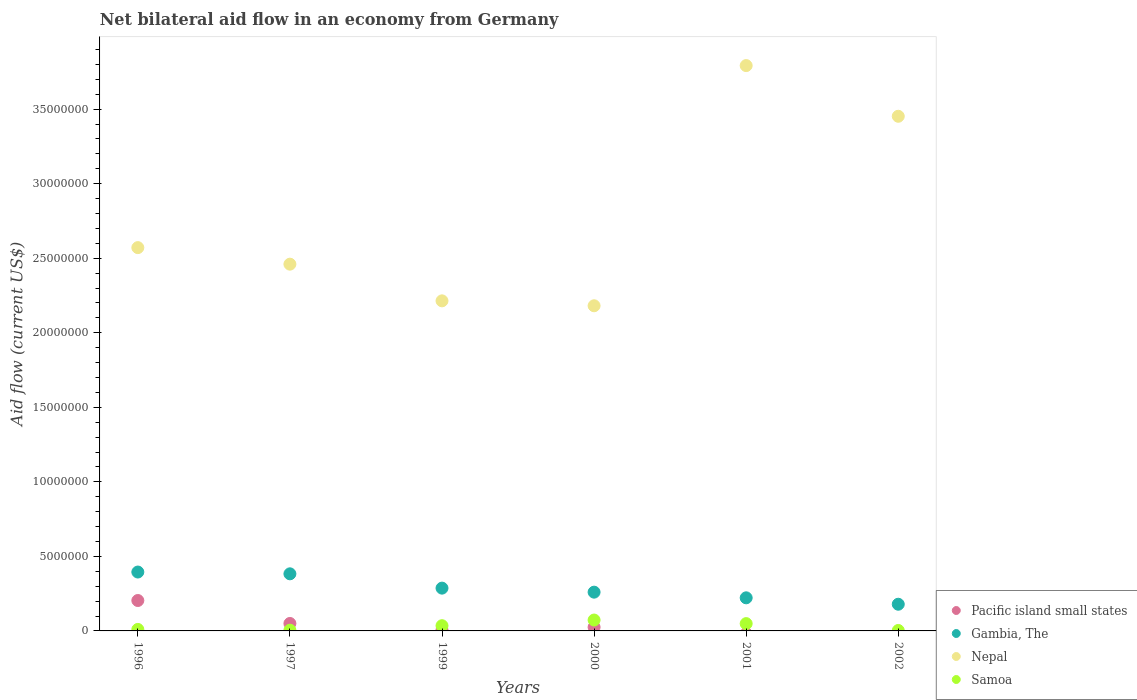How many different coloured dotlines are there?
Make the answer very short. 4. What is the net bilateral aid flow in Nepal in 1999?
Your response must be concise. 2.21e+07. Across all years, what is the maximum net bilateral aid flow in Pacific island small states?
Ensure brevity in your answer.  2.04e+06. Across all years, what is the minimum net bilateral aid flow in Samoa?
Your response must be concise. 3.00e+04. What is the total net bilateral aid flow in Nepal in the graph?
Your answer should be very brief. 1.67e+08. What is the difference between the net bilateral aid flow in Samoa in 1999 and that in 2000?
Give a very brief answer. -3.80e+05. What is the difference between the net bilateral aid flow in Samoa in 1999 and the net bilateral aid flow in Gambia, The in 1996?
Make the answer very short. -3.60e+06. What is the average net bilateral aid flow in Nepal per year?
Your response must be concise. 2.78e+07. In the year 1996, what is the difference between the net bilateral aid flow in Pacific island small states and net bilateral aid flow in Gambia, The?
Your answer should be very brief. -1.91e+06. In how many years, is the net bilateral aid flow in Nepal greater than 1000000 US$?
Keep it short and to the point. 6. What is the ratio of the net bilateral aid flow in Nepal in 1997 to that in 2002?
Keep it short and to the point. 0.71. Is the difference between the net bilateral aid flow in Pacific island small states in 1996 and 2000 greater than the difference between the net bilateral aid flow in Gambia, The in 1996 and 2000?
Provide a short and direct response. Yes. What is the difference between the highest and the second highest net bilateral aid flow in Samoa?
Keep it short and to the point. 2.40e+05. What is the difference between the highest and the lowest net bilateral aid flow in Nepal?
Your response must be concise. 1.61e+07. Is the sum of the net bilateral aid flow in Nepal in 2001 and 2002 greater than the maximum net bilateral aid flow in Gambia, The across all years?
Ensure brevity in your answer.  Yes. Is it the case that in every year, the sum of the net bilateral aid flow in Gambia, The and net bilateral aid flow in Samoa  is greater than the sum of net bilateral aid flow in Nepal and net bilateral aid flow in Pacific island small states?
Give a very brief answer. No. Is it the case that in every year, the sum of the net bilateral aid flow in Samoa and net bilateral aid flow in Gambia, The  is greater than the net bilateral aid flow in Pacific island small states?
Offer a very short reply. Yes. Is the net bilateral aid flow in Gambia, The strictly less than the net bilateral aid flow in Samoa over the years?
Ensure brevity in your answer.  No. How many years are there in the graph?
Provide a short and direct response. 6. Are the values on the major ticks of Y-axis written in scientific E-notation?
Offer a very short reply. No. Does the graph contain any zero values?
Provide a short and direct response. Yes. Does the graph contain grids?
Ensure brevity in your answer.  No. How many legend labels are there?
Ensure brevity in your answer.  4. How are the legend labels stacked?
Offer a very short reply. Vertical. What is the title of the graph?
Your response must be concise. Net bilateral aid flow in an economy from Germany. Does "Sudan" appear as one of the legend labels in the graph?
Make the answer very short. No. What is the Aid flow (current US$) in Pacific island small states in 1996?
Provide a succinct answer. 2.04e+06. What is the Aid flow (current US$) of Gambia, The in 1996?
Your answer should be very brief. 3.95e+06. What is the Aid flow (current US$) in Nepal in 1996?
Your response must be concise. 2.57e+07. What is the Aid flow (current US$) of Samoa in 1996?
Offer a very short reply. 1.00e+05. What is the Aid flow (current US$) of Gambia, The in 1997?
Make the answer very short. 3.83e+06. What is the Aid flow (current US$) in Nepal in 1997?
Make the answer very short. 2.46e+07. What is the Aid flow (current US$) in Gambia, The in 1999?
Offer a terse response. 2.87e+06. What is the Aid flow (current US$) of Nepal in 1999?
Offer a very short reply. 2.21e+07. What is the Aid flow (current US$) in Samoa in 1999?
Your answer should be compact. 3.50e+05. What is the Aid flow (current US$) in Pacific island small states in 2000?
Ensure brevity in your answer.  2.50e+05. What is the Aid flow (current US$) of Gambia, The in 2000?
Your response must be concise. 2.60e+06. What is the Aid flow (current US$) in Nepal in 2000?
Your answer should be compact. 2.18e+07. What is the Aid flow (current US$) in Samoa in 2000?
Your answer should be very brief. 7.30e+05. What is the Aid flow (current US$) of Gambia, The in 2001?
Your response must be concise. 2.22e+06. What is the Aid flow (current US$) of Nepal in 2001?
Your response must be concise. 3.79e+07. What is the Aid flow (current US$) in Pacific island small states in 2002?
Your response must be concise. 0. What is the Aid flow (current US$) in Gambia, The in 2002?
Your answer should be very brief. 1.79e+06. What is the Aid flow (current US$) of Nepal in 2002?
Keep it short and to the point. 3.45e+07. Across all years, what is the maximum Aid flow (current US$) in Pacific island small states?
Provide a short and direct response. 2.04e+06. Across all years, what is the maximum Aid flow (current US$) of Gambia, The?
Your response must be concise. 3.95e+06. Across all years, what is the maximum Aid flow (current US$) in Nepal?
Provide a succinct answer. 3.79e+07. Across all years, what is the maximum Aid flow (current US$) of Samoa?
Offer a terse response. 7.30e+05. Across all years, what is the minimum Aid flow (current US$) of Pacific island small states?
Your answer should be compact. 0. Across all years, what is the minimum Aid flow (current US$) in Gambia, The?
Provide a succinct answer. 1.79e+06. Across all years, what is the minimum Aid flow (current US$) of Nepal?
Ensure brevity in your answer.  2.18e+07. Across all years, what is the minimum Aid flow (current US$) in Samoa?
Your response must be concise. 3.00e+04. What is the total Aid flow (current US$) in Pacific island small states in the graph?
Give a very brief answer. 2.85e+06. What is the total Aid flow (current US$) in Gambia, The in the graph?
Your answer should be very brief. 1.73e+07. What is the total Aid flow (current US$) of Nepal in the graph?
Ensure brevity in your answer.  1.67e+08. What is the total Aid flow (current US$) in Samoa in the graph?
Offer a very short reply. 1.75e+06. What is the difference between the Aid flow (current US$) in Pacific island small states in 1996 and that in 1997?
Keep it short and to the point. 1.54e+06. What is the difference between the Aid flow (current US$) of Nepal in 1996 and that in 1997?
Keep it short and to the point. 1.11e+06. What is the difference between the Aid flow (current US$) of Pacific island small states in 1996 and that in 1999?
Offer a terse response. 1.98e+06. What is the difference between the Aid flow (current US$) in Gambia, The in 1996 and that in 1999?
Provide a short and direct response. 1.08e+06. What is the difference between the Aid flow (current US$) of Nepal in 1996 and that in 1999?
Provide a short and direct response. 3.57e+06. What is the difference between the Aid flow (current US$) of Pacific island small states in 1996 and that in 2000?
Keep it short and to the point. 1.79e+06. What is the difference between the Aid flow (current US$) in Gambia, The in 1996 and that in 2000?
Your answer should be very brief. 1.35e+06. What is the difference between the Aid flow (current US$) of Nepal in 1996 and that in 2000?
Give a very brief answer. 3.90e+06. What is the difference between the Aid flow (current US$) of Samoa in 1996 and that in 2000?
Your answer should be compact. -6.30e+05. What is the difference between the Aid flow (current US$) in Gambia, The in 1996 and that in 2001?
Ensure brevity in your answer.  1.73e+06. What is the difference between the Aid flow (current US$) in Nepal in 1996 and that in 2001?
Provide a succinct answer. -1.22e+07. What is the difference between the Aid flow (current US$) in Samoa in 1996 and that in 2001?
Offer a terse response. -3.90e+05. What is the difference between the Aid flow (current US$) in Gambia, The in 1996 and that in 2002?
Give a very brief answer. 2.16e+06. What is the difference between the Aid flow (current US$) of Nepal in 1996 and that in 2002?
Make the answer very short. -8.81e+06. What is the difference between the Aid flow (current US$) of Samoa in 1996 and that in 2002?
Provide a succinct answer. 7.00e+04. What is the difference between the Aid flow (current US$) of Gambia, The in 1997 and that in 1999?
Your response must be concise. 9.60e+05. What is the difference between the Aid flow (current US$) of Nepal in 1997 and that in 1999?
Offer a terse response. 2.46e+06. What is the difference between the Aid flow (current US$) in Samoa in 1997 and that in 1999?
Your response must be concise. -3.00e+05. What is the difference between the Aid flow (current US$) of Gambia, The in 1997 and that in 2000?
Your answer should be very brief. 1.23e+06. What is the difference between the Aid flow (current US$) in Nepal in 1997 and that in 2000?
Keep it short and to the point. 2.79e+06. What is the difference between the Aid flow (current US$) in Samoa in 1997 and that in 2000?
Offer a terse response. -6.80e+05. What is the difference between the Aid flow (current US$) of Gambia, The in 1997 and that in 2001?
Your response must be concise. 1.61e+06. What is the difference between the Aid flow (current US$) in Nepal in 1997 and that in 2001?
Give a very brief answer. -1.33e+07. What is the difference between the Aid flow (current US$) of Samoa in 1997 and that in 2001?
Provide a short and direct response. -4.40e+05. What is the difference between the Aid flow (current US$) in Gambia, The in 1997 and that in 2002?
Your answer should be compact. 2.04e+06. What is the difference between the Aid flow (current US$) of Nepal in 1997 and that in 2002?
Ensure brevity in your answer.  -9.92e+06. What is the difference between the Aid flow (current US$) in Samoa in 1997 and that in 2002?
Make the answer very short. 2.00e+04. What is the difference between the Aid flow (current US$) of Gambia, The in 1999 and that in 2000?
Your answer should be very brief. 2.70e+05. What is the difference between the Aid flow (current US$) in Nepal in 1999 and that in 2000?
Ensure brevity in your answer.  3.30e+05. What is the difference between the Aid flow (current US$) in Samoa in 1999 and that in 2000?
Your answer should be compact. -3.80e+05. What is the difference between the Aid flow (current US$) in Gambia, The in 1999 and that in 2001?
Give a very brief answer. 6.50e+05. What is the difference between the Aid flow (current US$) in Nepal in 1999 and that in 2001?
Make the answer very short. -1.58e+07. What is the difference between the Aid flow (current US$) in Gambia, The in 1999 and that in 2002?
Give a very brief answer. 1.08e+06. What is the difference between the Aid flow (current US$) in Nepal in 1999 and that in 2002?
Provide a succinct answer. -1.24e+07. What is the difference between the Aid flow (current US$) in Gambia, The in 2000 and that in 2001?
Your answer should be very brief. 3.80e+05. What is the difference between the Aid flow (current US$) of Nepal in 2000 and that in 2001?
Give a very brief answer. -1.61e+07. What is the difference between the Aid flow (current US$) in Gambia, The in 2000 and that in 2002?
Give a very brief answer. 8.10e+05. What is the difference between the Aid flow (current US$) in Nepal in 2000 and that in 2002?
Ensure brevity in your answer.  -1.27e+07. What is the difference between the Aid flow (current US$) in Gambia, The in 2001 and that in 2002?
Your response must be concise. 4.30e+05. What is the difference between the Aid flow (current US$) in Nepal in 2001 and that in 2002?
Provide a short and direct response. 3.40e+06. What is the difference between the Aid flow (current US$) of Samoa in 2001 and that in 2002?
Offer a terse response. 4.60e+05. What is the difference between the Aid flow (current US$) of Pacific island small states in 1996 and the Aid flow (current US$) of Gambia, The in 1997?
Ensure brevity in your answer.  -1.79e+06. What is the difference between the Aid flow (current US$) of Pacific island small states in 1996 and the Aid flow (current US$) of Nepal in 1997?
Your response must be concise. -2.26e+07. What is the difference between the Aid flow (current US$) of Pacific island small states in 1996 and the Aid flow (current US$) of Samoa in 1997?
Offer a terse response. 1.99e+06. What is the difference between the Aid flow (current US$) of Gambia, The in 1996 and the Aid flow (current US$) of Nepal in 1997?
Your answer should be compact. -2.06e+07. What is the difference between the Aid flow (current US$) of Gambia, The in 1996 and the Aid flow (current US$) of Samoa in 1997?
Give a very brief answer. 3.90e+06. What is the difference between the Aid flow (current US$) in Nepal in 1996 and the Aid flow (current US$) in Samoa in 1997?
Make the answer very short. 2.57e+07. What is the difference between the Aid flow (current US$) of Pacific island small states in 1996 and the Aid flow (current US$) of Gambia, The in 1999?
Your answer should be very brief. -8.30e+05. What is the difference between the Aid flow (current US$) of Pacific island small states in 1996 and the Aid flow (current US$) of Nepal in 1999?
Offer a very short reply. -2.01e+07. What is the difference between the Aid flow (current US$) of Pacific island small states in 1996 and the Aid flow (current US$) of Samoa in 1999?
Make the answer very short. 1.69e+06. What is the difference between the Aid flow (current US$) in Gambia, The in 1996 and the Aid flow (current US$) in Nepal in 1999?
Make the answer very short. -1.82e+07. What is the difference between the Aid flow (current US$) of Gambia, The in 1996 and the Aid flow (current US$) of Samoa in 1999?
Make the answer very short. 3.60e+06. What is the difference between the Aid flow (current US$) of Nepal in 1996 and the Aid flow (current US$) of Samoa in 1999?
Provide a succinct answer. 2.54e+07. What is the difference between the Aid flow (current US$) in Pacific island small states in 1996 and the Aid flow (current US$) in Gambia, The in 2000?
Offer a very short reply. -5.60e+05. What is the difference between the Aid flow (current US$) of Pacific island small states in 1996 and the Aid flow (current US$) of Nepal in 2000?
Ensure brevity in your answer.  -1.98e+07. What is the difference between the Aid flow (current US$) of Pacific island small states in 1996 and the Aid flow (current US$) of Samoa in 2000?
Ensure brevity in your answer.  1.31e+06. What is the difference between the Aid flow (current US$) in Gambia, The in 1996 and the Aid flow (current US$) in Nepal in 2000?
Give a very brief answer. -1.79e+07. What is the difference between the Aid flow (current US$) of Gambia, The in 1996 and the Aid flow (current US$) of Samoa in 2000?
Ensure brevity in your answer.  3.22e+06. What is the difference between the Aid flow (current US$) in Nepal in 1996 and the Aid flow (current US$) in Samoa in 2000?
Your response must be concise. 2.50e+07. What is the difference between the Aid flow (current US$) of Pacific island small states in 1996 and the Aid flow (current US$) of Nepal in 2001?
Provide a short and direct response. -3.59e+07. What is the difference between the Aid flow (current US$) of Pacific island small states in 1996 and the Aid flow (current US$) of Samoa in 2001?
Provide a short and direct response. 1.55e+06. What is the difference between the Aid flow (current US$) of Gambia, The in 1996 and the Aid flow (current US$) of Nepal in 2001?
Give a very brief answer. -3.40e+07. What is the difference between the Aid flow (current US$) of Gambia, The in 1996 and the Aid flow (current US$) of Samoa in 2001?
Provide a succinct answer. 3.46e+06. What is the difference between the Aid flow (current US$) in Nepal in 1996 and the Aid flow (current US$) in Samoa in 2001?
Give a very brief answer. 2.52e+07. What is the difference between the Aid flow (current US$) of Pacific island small states in 1996 and the Aid flow (current US$) of Gambia, The in 2002?
Your response must be concise. 2.50e+05. What is the difference between the Aid flow (current US$) in Pacific island small states in 1996 and the Aid flow (current US$) in Nepal in 2002?
Offer a terse response. -3.25e+07. What is the difference between the Aid flow (current US$) in Pacific island small states in 1996 and the Aid flow (current US$) in Samoa in 2002?
Your answer should be very brief. 2.01e+06. What is the difference between the Aid flow (current US$) in Gambia, The in 1996 and the Aid flow (current US$) in Nepal in 2002?
Offer a very short reply. -3.06e+07. What is the difference between the Aid flow (current US$) in Gambia, The in 1996 and the Aid flow (current US$) in Samoa in 2002?
Offer a terse response. 3.92e+06. What is the difference between the Aid flow (current US$) of Nepal in 1996 and the Aid flow (current US$) of Samoa in 2002?
Keep it short and to the point. 2.57e+07. What is the difference between the Aid flow (current US$) in Pacific island small states in 1997 and the Aid flow (current US$) in Gambia, The in 1999?
Your answer should be compact. -2.37e+06. What is the difference between the Aid flow (current US$) of Pacific island small states in 1997 and the Aid flow (current US$) of Nepal in 1999?
Give a very brief answer. -2.16e+07. What is the difference between the Aid flow (current US$) of Gambia, The in 1997 and the Aid flow (current US$) of Nepal in 1999?
Provide a succinct answer. -1.83e+07. What is the difference between the Aid flow (current US$) in Gambia, The in 1997 and the Aid flow (current US$) in Samoa in 1999?
Provide a succinct answer. 3.48e+06. What is the difference between the Aid flow (current US$) in Nepal in 1997 and the Aid flow (current US$) in Samoa in 1999?
Your answer should be very brief. 2.42e+07. What is the difference between the Aid flow (current US$) in Pacific island small states in 1997 and the Aid flow (current US$) in Gambia, The in 2000?
Your answer should be very brief. -2.10e+06. What is the difference between the Aid flow (current US$) of Pacific island small states in 1997 and the Aid flow (current US$) of Nepal in 2000?
Ensure brevity in your answer.  -2.13e+07. What is the difference between the Aid flow (current US$) in Gambia, The in 1997 and the Aid flow (current US$) in Nepal in 2000?
Provide a short and direct response. -1.80e+07. What is the difference between the Aid flow (current US$) in Gambia, The in 1997 and the Aid flow (current US$) in Samoa in 2000?
Keep it short and to the point. 3.10e+06. What is the difference between the Aid flow (current US$) of Nepal in 1997 and the Aid flow (current US$) of Samoa in 2000?
Make the answer very short. 2.39e+07. What is the difference between the Aid flow (current US$) of Pacific island small states in 1997 and the Aid flow (current US$) of Gambia, The in 2001?
Give a very brief answer. -1.72e+06. What is the difference between the Aid flow (current US$) in Pacific island small states in 1997 and the Aid flow (current US$) in Nepal in 2001?
Ensure brevity in your answer.  -3.74e+07. What is the difference between the Aid flow (current US$) in Pacific island small states in 1997 and the Aid flow (current US$) in Samoa in 2001?
Offer a terse response. 10000. What is the difference between the Aid flow (current US$) of Gambia, The in 1997 and the Aid flow (current US$) of Nepal in 2001?
Your answer should be very brief. -3.41e+07. What is the difference between the Aid flow (current US$) of Gambia, The in 1997 and the Aid flow (current US$) of Samoa in 2001?
Your answer should be very brief. 3.34e+06. What is the difference between the Aid flow (current US$) of Nepal in 1997 and the Aid flow (current US$) of Samoa in 2001?
Offer a very short reply. 2.41e+07. What is the difference between the Aid flow (current US$) in Pacific island small states in 1997 and the Aid flow (current US$) in Gambia, The in 2002?
Your answer should be compact. -1.29e+06. What is the difference between the Aid flow (current US$) in Pacific island small states in 1997 and the Aid flow (current US$) in Nepal in 2002?
Offer a very short reply. -3.40e+07. What is the difference between the Aid flow (current US$) in Pacific island small states in 1997 and the Aid flow (current US$) in Samoa in 2002?
Make the answer very short. 4.70e+05. What is the difference between the Aid flow (current US$) of Gambia, The in 1997 and the Aid flow (current US$) of Nepal in 2002?
Make the answer very short. -3.07e+07. What is the difference between the Aid flow (current US$) of Gambia, The in 1997 and the Aid flow (current US$) of Samoa in 2002?
Make the answer very short. 3.80e+06. What is the difference between the Aid flow (current US$) of Nepal in 1997 and the Aid flow (current US$) of Samoa in 2002?
Offer a terse response. 2.46e+07. What is the difference between the Aid flow (current US$) in Pacific island small states in 1999 and the Aid flow (current US$) in Gambia, The in 2000?
Provide a succinct answer. -2.54e+06. What is the difference between the Aid flow (current US$) of Pacific island small states in 1999 and the Aid flow (current US$) of Nepal in 2000?
Provide a succinct answer. -2.18e+07. What is the difference between the Aid flow (current US$) in Pacific island small states in 1999 and the Aid flow (current US$) in Samoa in 2000?
Your answer should be compact. -6.70e+05. What is the difference between the Aid flow (current US$) of Gambia, The in 1999 and the Aid flow (current US$) of Nepal in 2000?
Give a very brief answer. -1.89e+07. What is the difference between the Aid flow (current US$) in Gambia, The in 1999 and the Aid flow (current US$) in Samoa in 2000?
Give a very brief answer. 2.14e+06. What is the difference between the Aid flow (current US$) in Nepal in 1999 and the Aid flow (current US$) in Samoa in 2000?
Ensure brevity in your answer.  2.14e+07. What is the difference between the Aid flow (current US$) of Pacific island small states in 1999 and the Aid flow (current US$) of Gambia, The in 2001?
Offer a very short reply. -2.16e+06. What is the difference between the Aid flow (current US$) in Pacific island small states in 1999 and the Aid flow (current US$) in Nepal in 2001?
Provide a short and direct response. -3.79e+07. What is the difference between the Aid flow (current US$) in Pacific island small states in 1999 and the Aid flow (current US$) in Samoa in 2001?
Your response must be concise. -4.30e+05. What is the difference between the Aid flow (current US$) in Gambia, The in 1999 and the Aid flow (current US$) in Nepal in 2001?
Provide a succinct answer. -3.50e+07. What is the difference between the Aid flow (current US$) of Gambia, The in 1999 and the Aid flow (current US$) of Samoa in 2001?
Keep it short and to the point. 2.38e+06. What is the difference between the Aid flow (current US$) in Nepal in 1999 and the Aid flow (current US$) in Samoa in 2001?
Your answer should be compact. 2.16e+07. What is the difference between the Aid flow (current US$) of Pacific island small states in 1999 and the Aid flow (current US$) of Gambia, The in 2002?
Your answer should be compact. -1.73e+06. What is the difference between the Aid flow (current US$) of Pacific island small states in 1999 and the Aid flow (current US$) of Nepal in 2002?
Offer a very short reply. -3.45e+07. What is the difference between the Aid flow (current US$) of Gambia, The in 1999 and the Aid flow (current US$) of Nepal in 2002?
Ensure brevity in your answer.  -3.16e+07. What is the difference between the Aid flow (current US$) in Gambia, The in 1999 and the Aid flow (current US$) in Samoa in 2002?
Your answer should be compact. 2.84e+06. What is the difference between the Aid flow (current US$) in Nepal in 1999 and the Aid flow (current US$) in Samoa in 2002?
Ensure brevity in your answer.  2.21e+07. What is the difference between the Aid flow (current US$) of Pacific island small states in 2000 and the Aid flow (current US$) of Gambia, The in 2001?
Offer a terse response. -1.97e+06. What is the difference between the Aid flow (current US$) of Pacific island small states in 2000 and the Aid flow (current US$) of Nepal in 2001?
Offer a very short reply. -3.77e+07. What is the difference between the Aid flow (current US$) of Gambia, The in 2000 and the Aid flow (current US$) of Nepal in 2001?
Provide a succinct answer. -3.53e+07. What is the difference between the Aid flow (current US$) in Gambia, The in 2000 and the Aid flow (current US$) in Samoa in 2001?
Offer a very short reply. 2.11e+06. What is the difference between the Aid flow (current US$) of Nepal in 2000 and the Aid flow (current US$) of Samoa in 2001?
Your answer should be compact. 2.13e+07. What is the difference between the Aid flow (current US$) of Pacific island small states in 2000 and the Aid flow (current US$) of Gambia, The in 2002?
Give a very brief answer. -1.54e+06. What is the difference between the Aid flow (current US$) of Pacific island small states in 2000 and the Aid flow (current US$) of Nepal in 2002?
Provide a succinct answer. -3.43e+07. What is the difference between the Aid flow (current US$) of Pacific island small states in 2000 and the Aid flow (current US$) of Samoa in 2002?
Your response must be concise. 2.20e+05. What is the difference between the Aid flow (current US$) of Gambia, The in 2000 and the Aid flow (current US$) of Nepal in 2002?
Ensure brevity in your answer.  -3.19e+07. What is the difference between the Aid flow (current US$) of Gambia, The in 2000 and the Aid flow (current US$) of Samoa in 2002?
Give a very brief answer. 2.57e+06. What is the difference between the Aid flow (current US$) of Nepal in 2000 and the Aid flow (current US$) of Samoa in 2002?
Give a very brief answer. 2.18e+07. What is the difference between the Aid flow (current US$) of Gambia, The in 2001 and the Aid flow (current US$) of Nepal in 2002?
Your answer should be compact. -3.23e+07. What is the difference between the Aid flow (current US$) in Gambia, The in 2001 and the Aid flow (current US$) in Samoa in 2002?
Offer a terse response. 2.19e+06. What is the difference between the Aid flow (current US$) in Nepal in 2001 and the Aid flow (current US$) in Samoa in 2002?
Ensure brevity in your answer.  3.79e+07. What is the average Aid flow (current US$) in Pacific island small states per year?
Provide a short and direct response. 4.75e+05. What is the average Aid flow (current US$) in Gambia, The per year?
Give a very brief answer. 2.88e+06. What is the average Aid flow (current US$) in Nepal per year?
Your answer should be very brief. 2.78e+07. What is the average Aid flow (current US$) of Samoa per year?
Provide a succinct answer. 2.92e+05. In the year 1996, what is the difference between the Aid flow (current US$) of Pacific island small states and Aid flow (current US$) of Gambia, The?
Keep it short and to the point. -1.91e+06. In the year 1996, what is the difference between the Aid flow (current US$) in Pacific island small states and Aid flow (current US$) in Nepal?
Provide a succinct answer. -2.37e+07. In the year 1996, what is the difference between the Aid flow (current US$) of Pacific island small states and Aid flow (current US$) of Samoa?
Your answer should be compact. 1.94e+06. In the year 1996, what is the difference between the Aid flow (current US$) of Gambia, The and Aid flow (current US$) of Nepal?
Ensure brevity in your answer.  -2.18e+07. In the year 1996, what is the difference between the Aid flow (current US$) of Gambia, The and Aid flow (current US$) of Samoa?
Ensure brevity in your answer.  3.85e+06. In the year 1996, what is the difference between the Aid flow (current US$) in Nepal and Aid flow (current US$) in Samoa?
Your answer should be compact. 2.56e+07. In the year 1997, what is the difference between the Aid flow (current US$) in Pacific island small states and Aid flow (current US$) in Gambia, The?
Your answer should be compact. -3.33e+06. In the year 1997, what is the difference between the Aid flow (current US$) of Pacific island small states and Aid flow (current US$) of Nepal?
Your answer should be very brief. -2.41e+07. In the year 1997, what is the difference between the Aid flow (current US$) in Gambia, The and Aid flow (current US$) in Nepal?
Provide a succinct answer. -2.08e+07. In the year 1997, what is the difference between the Aid flow (current US$) of Gambia, The and Aid flow (current US$) of Samoa?
Your response must be concise. 3.78e+06. In the year 1997, what is the difference between the Aid flow (current US$) of Nepal and Aid flow (current US$) of Samoa?
Offer a terse response. 2.46e+07. In the year 1999, what is the difference between the Aid flow (current US$) of Pacific island small states and Aid flow (current US$) of Gambia, The?
Offer a very short reply. -2.81e+06. In the year 1999, what is the difference between the Aid flow (current US$) in Pacific island small states and Aid flow (current US$) in Nepal?
Provide a short and direct response. -2.21e+07. In the year 1999, what is the difference between the Aid flow (current US$) in Pacific island small states and Aid flow (current US$) in Samoa?
Give a very brief answer. -2.90e+05. In the year 1999, what is the difference between the Aid flow (current US$) of Gambia, The and Aid flow (current US$) of Nepal?
Provide a succinct answer. -1.93e+07. In the year 1999, what is the difference between the Aid flow (current US$) of Gambia, The and Aid flow (current US$) of Samoa?
Offer a very short reply. 2.52e+06. In the year 1999, what is the difference between the Aid flow (current US$) of Nepal and Aid flow (current US$) of Samoa?
Make the answer very short. 2.18e+07. In the year 2000, what is the difference between the Aid flow (current US$) in Pacific island small states and Aid flow (current US$) in Gambia, The?
Ensure brevity in your answer.  -2.35e+06. In the year 2000, what is the difference between the Aid flow (current US$) of Pacific island small states and Aid flow (current US$) of Nepal?
Provide a succinct answer. -2.16e+07. In the year 2000, what is the difference between the Aid flow (current US$) of Pacific island small states and Aid flow (current US$) of Samoa?
Offer a terse response. -4.80e+05. In the year 2000, what is the difference between the Aid flow (current US$) of Gambia, The and Aid flow (current US$) of Nepal?
Ensure brevity in your answer.  -1.92e+07. In the year 2000, what is the difference between the Aid flow (current US$) in Gambia, The and Aid flow (current US$) in Samoa?
Keep it short and to the point. 1.87e+06. In the year 2000, what is the difference between the Aid flow (current US$) of Nepal and Aid flow (current US$) of Samoa?
Provide a short and direct response. 2.11e+07. In the year 2001, what is the difference between the Aid flow (current US$) of Gambia, The and Aid flow (current US$) of Nepal?
Make the answer very short. -3.57e+07. In the year 2001, what is the difference between the Aid flow (current US$) of Gambia, The and Aid flow (current US$) of Samoa?
Your answer should be compact. 1.73e+06. In the year 2001, what is the difference between the Aid flow (current US$) of Nepal and Aid flow (current US$) of Samoa?
Ensure brevity in your answer.  3.74e+07. In the year 2002, what is the difference between the Aid flow (current US$) in Gambia, The and Aid flow (current US$) in Nepal?
Provide a short and direct response. -3.27e+07. In the year 2002, what is the difference between the Aid flow (current US$) in Gambia, The and Aid flow (current US$) in Samoa?
Your answer should be very brief. 1.76e+06. In the year 2002, what is the difference between the Aid flow (current US$) of Nepal and Aid flow (current US$) of Samoa?
Keep it short and to the point. 3.45e+07. What is the ratio of the Aid flow (current US$) in Pacific island small states in 1996 to that in 1997?
Offer a terse response. 4.08. What is the ratio of the Aid flow (current US$) in Gambia, The in 1996 to that in 1997?
Give a very brief answer. 1.03. What is the ratio of the Aid flow (current US$) in Nepal in 1996 to that in 1997?
Your answer should be very brief. 1.05. What is the ratio of the Aid flow (current US$) in Samoa in 1996 to that in 1997?
Your answer should be compact. 2. What is the ratio of the Aid flow (current US$) of Pacific island small states in 1996 to that in 1999?
Make the answer very short. 34. What is the ratio of the Aid flow (current US$) of Gambia, The in 1996 to that in 1999?
Provide a succinct answer. 1.38. What is the ratio of the Aid flow (current US$) of Nepal in 1996 to that in 1999?
Your answer should be compact. 1.16. What is the ratio of the Aid flow (current US$) in Samoa in 1996 to that in 1999?
Provide a short and direct response. 0.29. What is the ratio of the Aid flow (current US$) in Pacific island small states in 1996 to that in 2000?
Offer a very short reply. 8.16. What is the ratio of the Aid flow (current US$) in Gambia, The in 1996 to that in 2000?
Your answer should be very brief. 1.52. What is the ratio of the Aid flow (current US$) in Nepal in 1996 to that in 2000?
Your response must be concise. 1.18. What is the ratio of the Aid flow (current US$) of Samoa in 1996 to that in 2000?
Offer a very short reply. 0.14. What is the ratio of the Aid flow (current US$) of Gambia, The in 1996 to that in 2001?
Your answer should be compact. 1.78. What is the ratio of the Aid flow (current US$) in Nepal in 1996 to that in 2001?
Offer a very short reply. 0.68. What is the ratio of the Aid flow (current US$) in Samoa in 1996 to that in 2001?
Ensure brevity in your answer.  0.2. What is the ratio of the Aid flow (current US$) of Gambia, The in 1996 to that in 2002?
Provide a short and direct response. 2.21. What is the ratio of the Aid flow (current US$) in Nepal in 1996 to that in 2002?
Offer a very short reply. 0.74. What is the ratio of the Aid flow (current US$) of Samoa in 1996 to that in 2002?
Offer a terse response. 3.33. What is the ratio of the Aid flow (current US$) in Pacific island small states in 1997 to that in 1999?
Keep it short and to the point. 8.33. What is the ratio of the Aid flow (current US$) in Gambia, The in 1997 to that in 1999?
Provide a short and direct response. 1.33. What is the ratio of the Aid flow (current US$) of Nepal in 1997 to that in 1999?
Offer a terse response. 1.11. What is the ratio of the Aid flow (current US$) in Samoa in 1997 to that in 1999?
Keep it short and to the point. 0.14. What is the ratio of the Aid flow (current US$) of Pacific island small states in 1997 to that in 2000?
Keep it short and to the point. 2. What is the ratio of the Aid flow (current US$) of Gambia, The in 1997 to that in 2000?
Your response must be concise. 1.47. What is the ratio of the Aid flow (current US$) in Nepal in 1997 to that in 2000?
Ensure brevity in your answer.  1.13. What is the ratio of the Aid flow (current US$) of Samoa in 1997 to that in 2000?
Ensure brevity in your answer.  0.07. What is the ratio of the Aid flow (current US$) of Gambia, The in 1997 to that in 2001?
Your answer should be very brief. 1.73. What is the ratio of the Aid flow (current US$) of Nepal in 1997 to that in 2001?
Offer a very short reply. 0.65. What is the ratio of the Aid flow (current US$) in Samoa in 1997 to that in 2001?
Provide a short and direct response. 0.1. What is the ratio of the Aid flow (current US$) in Gambia, The in 1997 to that in 2002?
Your answer should be very brief. 2.14. What is the ratio of the Aid flow (current US$) in Nepal in 1997 to that in 2002?
Your answer should be compact. 0.71. What is the ratio of the Aid flow (current US$) of Samoa in 1997 to that in 2002?
Offer a very short reply. 1.67. What is the ratio of the Aid flow (current US$) of Pacific island small states in 1999 to that in 2000?
Keep it short and to the point. 0.24. What is the ratio of the Aid flow (current US$) in Gambia, The in 1999 to that in 2000?
Ensure brevity in your answer.  1.1. What is the ratio of the Aid flow (current US$) of Nepal in 1999 to that in 2000?
Your answer should be compact. 1.02. What is the ratio of the Aid flow (current US$) in Samoa in 1999 to that in 2000?
Keep it short and to the point. 0.48. What is the ratio of the Aid flow (current US$) in Gambia, The in 1999 to that in 2001?
Provide a short and direct response. 1.29. What is the ratio of the Aid flow (current US$) of Nepal in 1999 to that in 2001?
Your answer should be very brief. 0.58. What is the ratio of the Aid flow (current US$) in Samoa in 1999 to that in 2001?
Keep it short and to the point. 0.71. What is the ratio of the Aid flow (current US$) in Gambia, The in 1999 to that in 2002?
Ensure brevity in your answer.  1.6. What is the ratio of the Aid flow (current US$) of Nepal in 1999 to that in 2002?
Provide a succinct answer. 0.64. What is the ratio of the Aid flow (current US$) of Samoa in 1999 to that in 2002?
Make the answer very short. 11.67. What is the ratio of the Aid flow (current US$) in Gambia, The in 2000 to that in 2001?
Give a very brief answer. 1.17. What is the ratio of the Aid flow (current US$) in Nepal in 2000 to that in 2001?
Offer a very short reply. 0.58. What is the ratio of the Aid flow (current US$) in Samoa in 2000 to that in 2001?
Keep it short and to the point. 1.49. What is the ratio of the Aid flow (current US$) of Gambia, The in 2000 to that in 2002?
Give a very brief answer. 1.45. What is the ratio of the Aid flow (current US$) in Nepal in 2000 to that in 2002?
Keep it short and to the point. 0.63. What is the ratio of the Aid flow (current US$) of Samoa in 2000 to that in 2002?
Keep it short and to the point. 24.33. What is the ratio of the Aid flow (current US$) in Gambia, The in 2001 to that in 2002?
Your answer should be very brief. 1.24. What is the ratio of the Aid flow (current US$) in Nepal in 2001 to that in 2002?
Your answer should be very brief. 1.1. What is the ratio of the Aid flow (current US$) of Samoa in 2001 to that in 2002?
Your answer should be compact. 16.33. What is the difference between the highest and the second highest Aid flow (current US$) in Pacific island small states?
Make the answer very short. 1.54e+06. What is the difference between the highest and the second highest Aid flow (current US$) in Nepal?
Provide a succinct answer. 3.40e+06. What is the difference between the highest and the lowest Aid flow (current US$) of Pacific island small states?
Provide a succinct answer. 2.04e+06. What is the difference between the highest and the lowest Aid flow (current US$) of Gambia, The?
Your response must be concise. 2.16e+06. What is the difference between the highest and the lowest Aid flow (current US$) in Nepal?
Offer a terse response. 1.61e+07. 